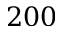<formula> <loc_0><loc_0><loc_500><loc_500>2 0 0</formula> 